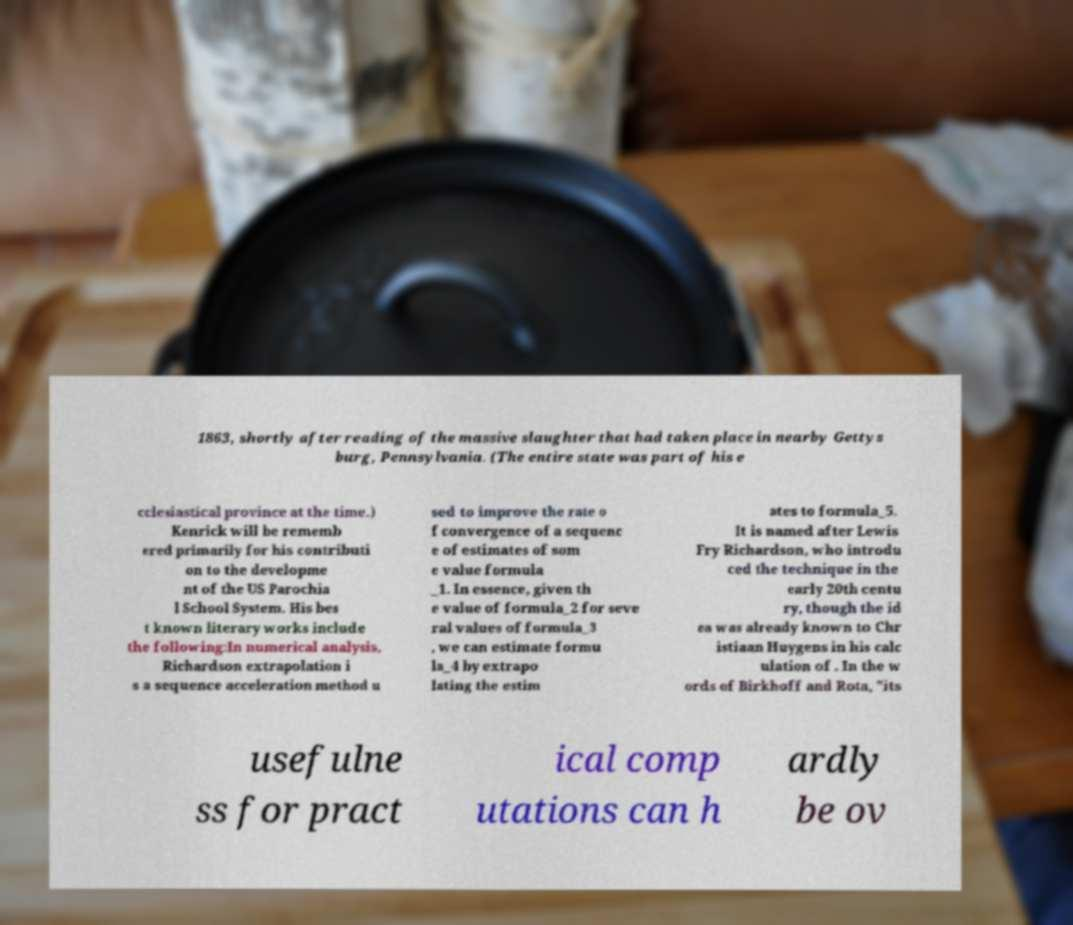There's text embedded in this image that I need extracted. Can you transcribe it verbatim? 1863, shortly after reading of the massive slaughter that had taken place in nearby Gettys burg, Pennsylvania. (The entire state was part of his e cclesiastical province at the time.) Kenrick will be rememb ered primarily for his contributi on to the developme nt of the US Parochia l School System. His bes t known literary works include the following:In numerical analysis, Richardson extrapolation i s a sequence acceleration method u sed to improve the rate o f convergence of a sequenc e of estimates of som e value formula _1. In essence, given th e value of formula_2 for seve ral values of formula_3 , we can estimate formu la_4 by extrapo lating the estim ates to formula_5. It is named after Lewis Fry Richardson, who introdu ced the technique in the early 20th centu ry, though the id ea was already known to Chr istiaan Huygens in his calc ulation of . In the w ords of Birkhoff and Rota, "its usefulne ss for pract ical comp utations can h ardly be ov 